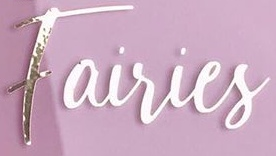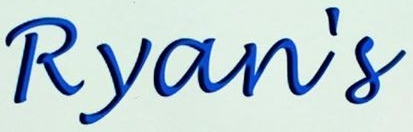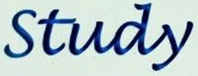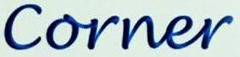What words are shown in these images in order, separated by a semicolon? Fairies; Ryan's; Study; Corner 